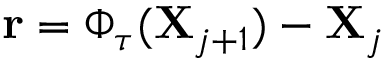<formula> <loc_0><loc_0><loc_500><loc_500>r = \Phi _ { \tau } ( X _ { j + 1 } ) - X _ { j }</formula> 